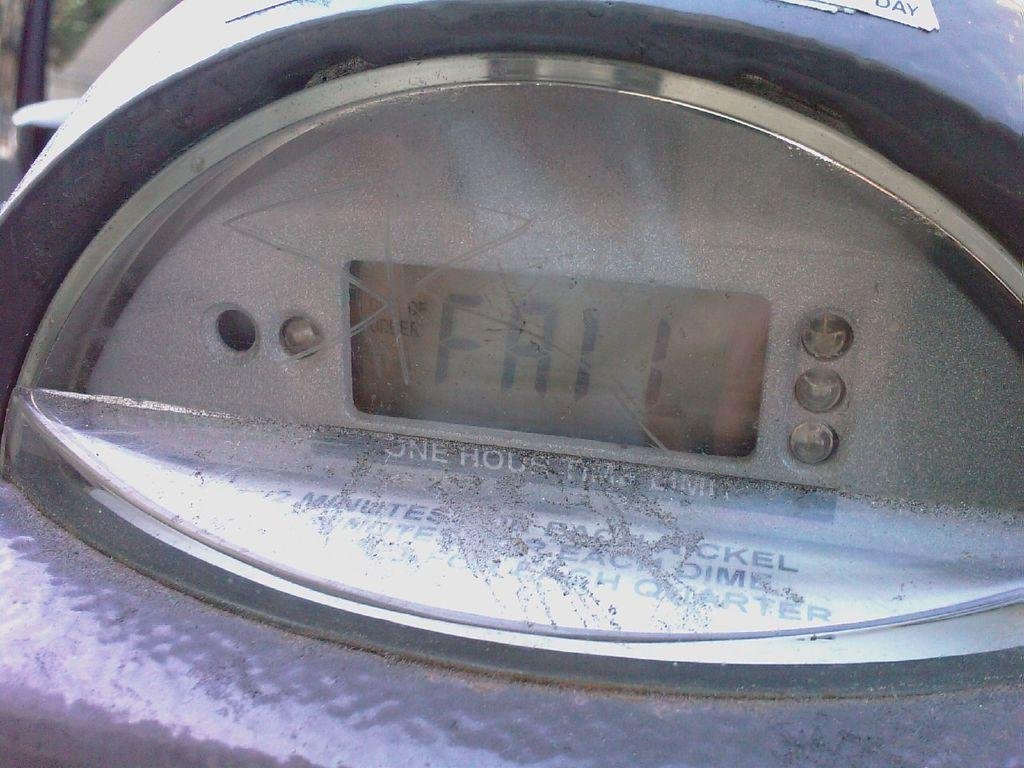<image>
Offer a succinct explanation of the picture presented. A parking meter's digital display says FAIL on it. 